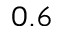Convert formula to latex. <formula><loc_0><loc_0><loc_500><loc_500>0 . 6</formula> 